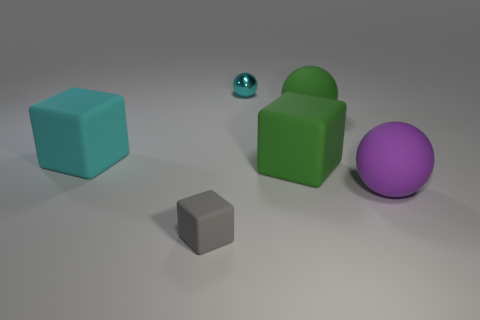How many metal balls are behind the tiny matte thing?
Your answer should be compact. 1. There is a gray object that is made of the same material as the green cube; what is its shape?
Offer a very short reply. Cube. Does the object in front of the large purple object have the same shape as the big cyan matte object?
Your response must be concise. Yes. What number of yellow things are either small spheres or big rubber cubes?
Provide a short and direct response. 0. Are there the same number of big green blocks in front of the gray matte thing and rubber spheres in front of the small metallic object?
Provide a succinct answer. No. There is a big rubber object that is in front of the big block that is on the right side of the small object in front of the cyan shiny sphere; what is its color?
Make the answer very short. Purple. Are there any other things of the same color as the metallic object?
Make the answer very short. Yes. What is the shape of the rubber object that is the same color as the tiny ball?
Your response must be concise. Cube. There is a cyan object to the right of the tiny gray matte block; how big is it?
Your answer should be very brief. Small. There is a purple rubber thing that is the same size as the cyan matte cube; what is its shape?
Provide a short and direct response. Sphere. 